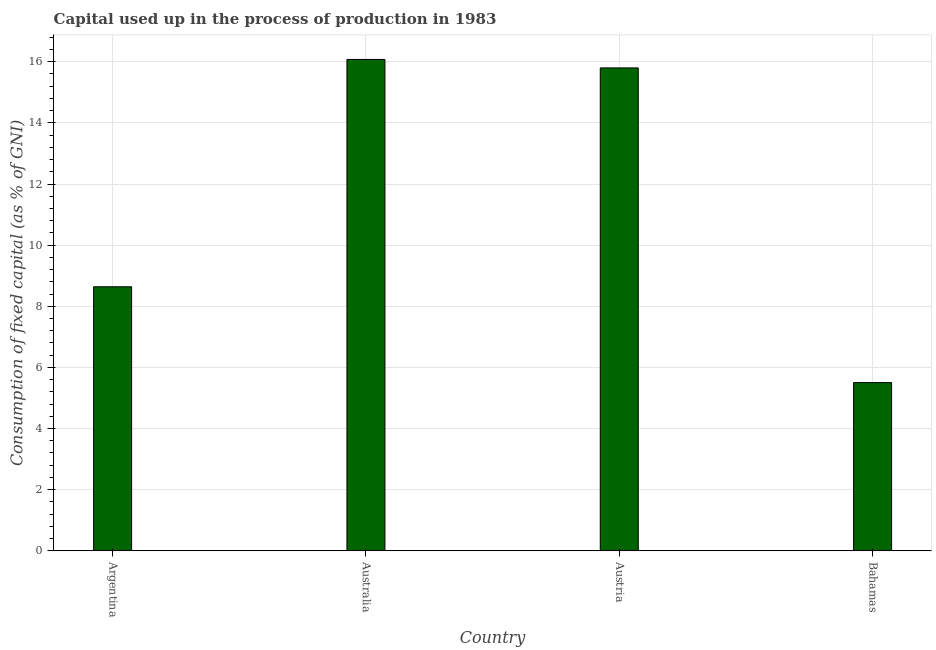What is the title of the graph?
Ensure brevity in your answer.  Capital used up in the process of production in 1983. What is the label or title of the X-axis?
Give a very brief answer. Country. What is the label or title of the Y-axis?
Your answer should be very brief. Consumption of fixed capital (as % of GNI). What is the consumption of fixed capital in Austria?
Ensure brevity in your answer.  15.8. Across all countries, what is the maximum consumption of fixed capital?
Give a very brief answer. 16.08. Across all countries, what is the minimum consumption of fixed capital?
Your response must be concise. 5.5. In which country was the consumption of fixed capital minimum?
Your answer should be very brief. Bahamas. What is the sum of the consumption of fixed capital?
Keep it short and to the point. 46.02. What is the difference between the consumption of fixed capital in Austria and Bahamas?
Offer a very short reply. 10.3. What is the average consumption of fixed capital per country?
Ensure brevity in your answer.  11.5. What is the median consumption of fixed capital?
Ensure brevity in your answer.  12.22. In how many countries, is the consumption of fixed capital greater than 7.2 %?
Keep it short and to the point. 3. What is the ratio of the consumption of fixed capital in Austria to that in Bahamas?
Give a very brief answer. 2.87. What is the difference between the highest and the second highest consumption of fixed capital?
Your response must be concise. 0.28. What is the difference between the highest and the lowest consumption of fixed capital?
Offer a terse response. 10.57. How many bars are there?
Your answer should be compact. 4. Are all the bars in the graph horizontal?
Your response must be concise. No. How many countries are there in the graph?
Make the answer very short. 4. What is the Consumption of fixed capital (as % of GNI) of Argentina?
Your answer should be very brief. 8.64. What is the Consumption of fixed capital (as % of GNI) of Australia?
Your response must be concise. 16.08. What is the Consumption of fixed capital (as % of GNI) in Austria?
Provide a short and direct response. 15.8. What is the Consumption of fixed capital (as % of GNI) of Bahamas?
Keep it short and to the point. 5.5. What is the difference between the Consumption of fixed capital (as % of GNI) in Argentina and Australia?
Offer a terse response. -7.44. What is the difference between the Consumption of fixed capital (as % of GNI) in Argentina and Austria?
Give a very brief answer. -7.16. What is the difference between the Consumption of fixed capital (as % of GNI) in Argentina and Bahamas?
Provide a short and direct response. 3.14. What is the difference between the Consumption of fixed capital (as % of GNI) in Australia and Austria?
Provide a succinct answer. 0.28. What is the difference between the Consumption of fixed capital (as % of GNI) in Australia and Bahamas?
Make the answer very short. 10.57. What is the difference between the Consumption of fixed capital (as % of GNI) in Austria and Bahamas?
Make the answer very short. 10.3. What is the ratio of the Consumption of fixed capital (as % of GNI) in Argentina to that in Australia?
Your answer should be very brief. 0.54. What is the ratio of the Consumption of fixed capital (as % of GNI) in Argentina to that in Austria?
Provide a succinct answer. 0.55. What is the ratio of the Consumption of fixed capital (as % of GNI) in Argentina to that in Bahamas?
Provide a succinct answer. 1.57. What is the ratio of the Consumption of fixed capital (as % of GNI) in Australia to that in Austria?
Give a very brief answer. 1.02. What is the ratio of the Consumption of fixed capital (as % of GNI) in Australia to that in Bahamas?
Your answer should be compact. 2.92. What is the ratio of the Consumption of fixed capital (as % of GNI) in Austria to that in Bahamas?
Provide a short and direct response. 2.87. 